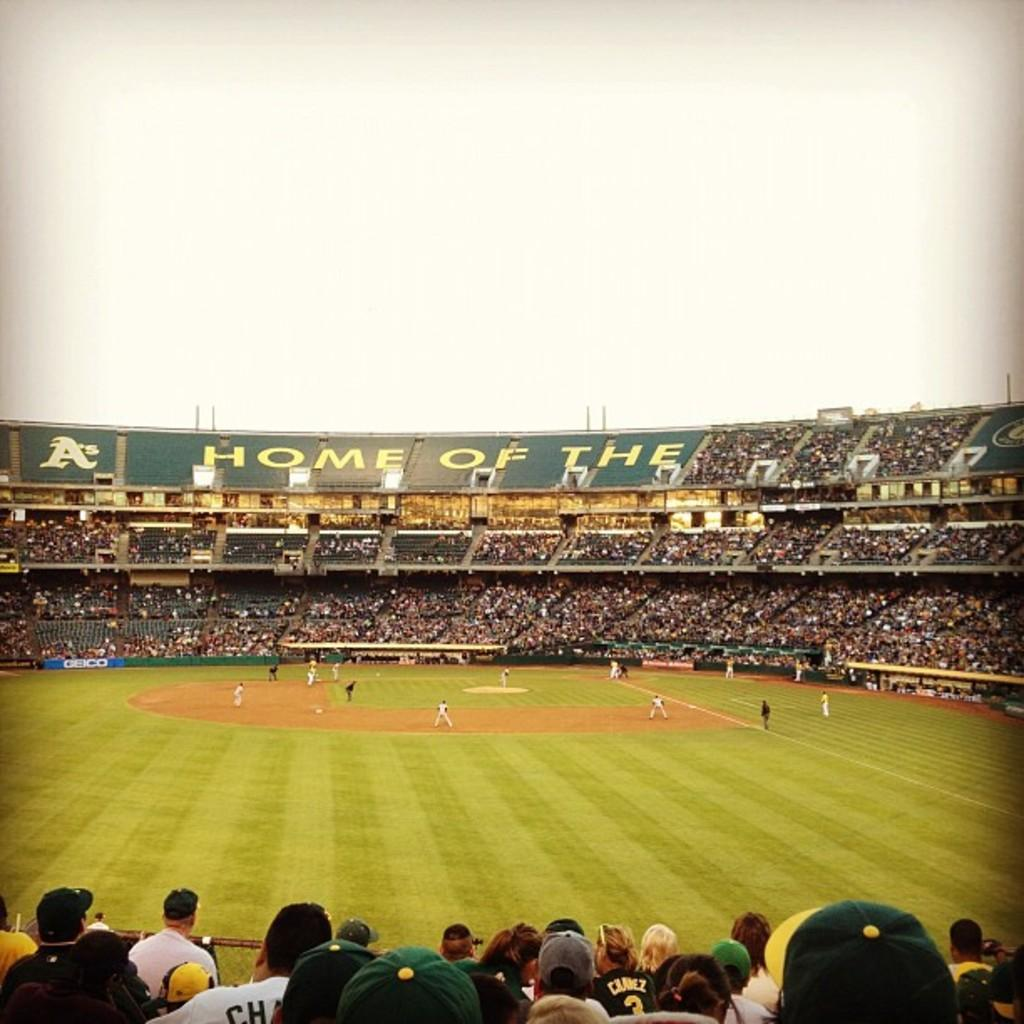Provide a one-sentence caption for the provided image. A stadium contains the word HOME on one of its walls. 